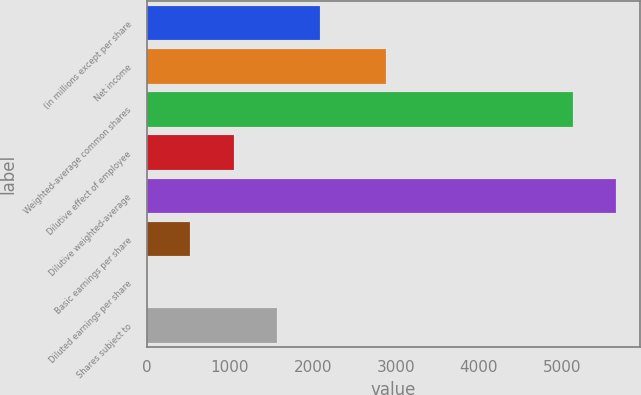Convert chart to OTSL. <chart><loc_0><loc_0><loc_500><loc_500><bar_chart><fcel>(in millions except per share<fcel>Net income<fcel>Weighted-average common shares<fcel>Dilutive effect of employee<fcel>Dilutive weighted-average<fcel>Basic earnings per share<fcel>Diluted earnings per share<fcel>Shares subject to<nl><fcel>2092.72<fcel>2886<fcel>5136<fcel>1046.63<fcel>5659.05<fcel>523.59<fcel>0.55<fcel>1569.68<nl></chart> 